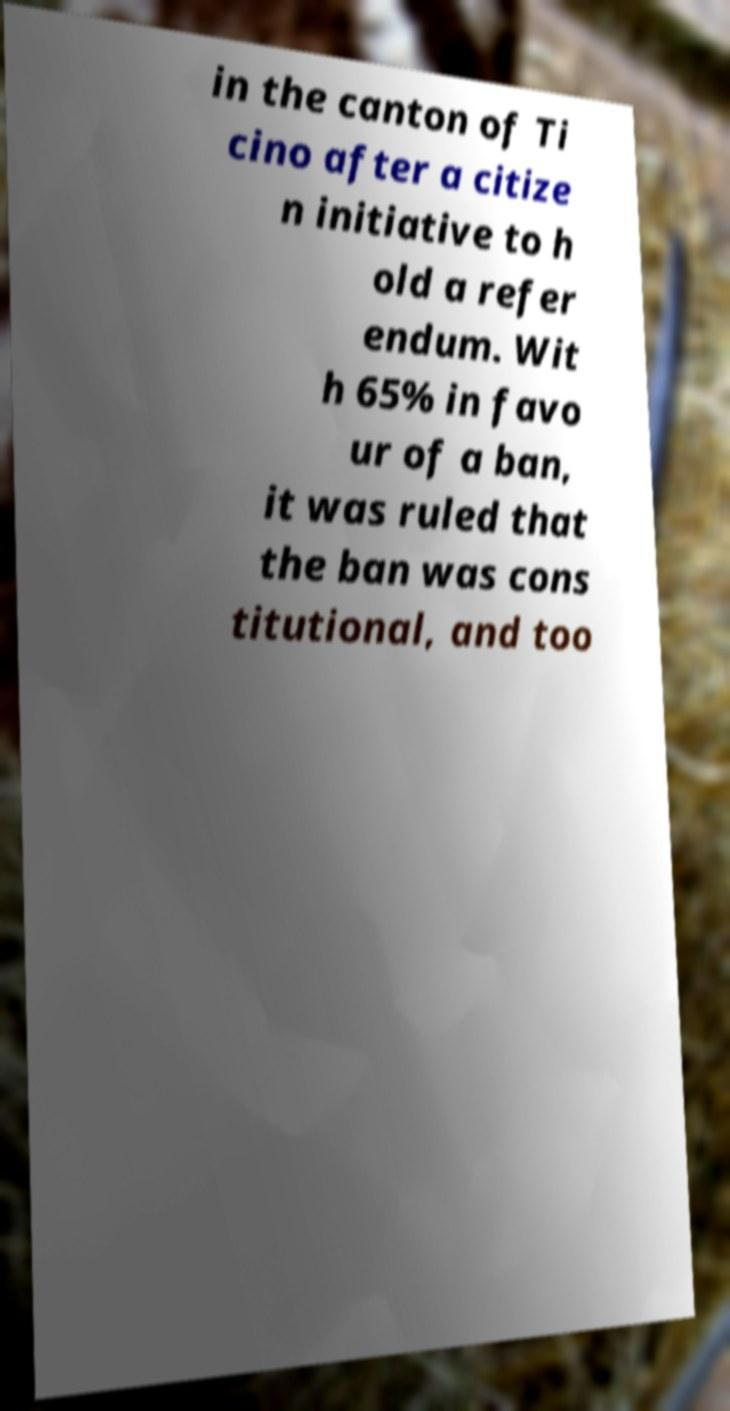There's text embedded in this image that I need extracted. Can you transcribe it verbatim? in the canton of Ti cino after a citize n initiative to h old a refer endum. Wit h 65% in favo ur of a ban, it was ruled that the ban was cons titutional, and too 